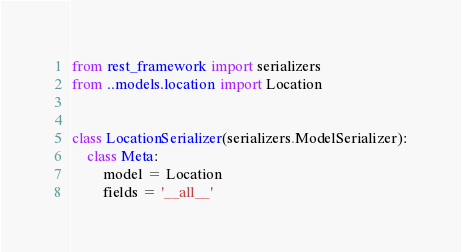<code> <loc_0><loc_0><loc_500><loc_500><_Python_>from rest_framework import serializers
from ..models.location import Location


class LocationSerializer(serializers.ModelSerializer):
    class Meta:
        model = Location
        fields = '__all__'
</code> 